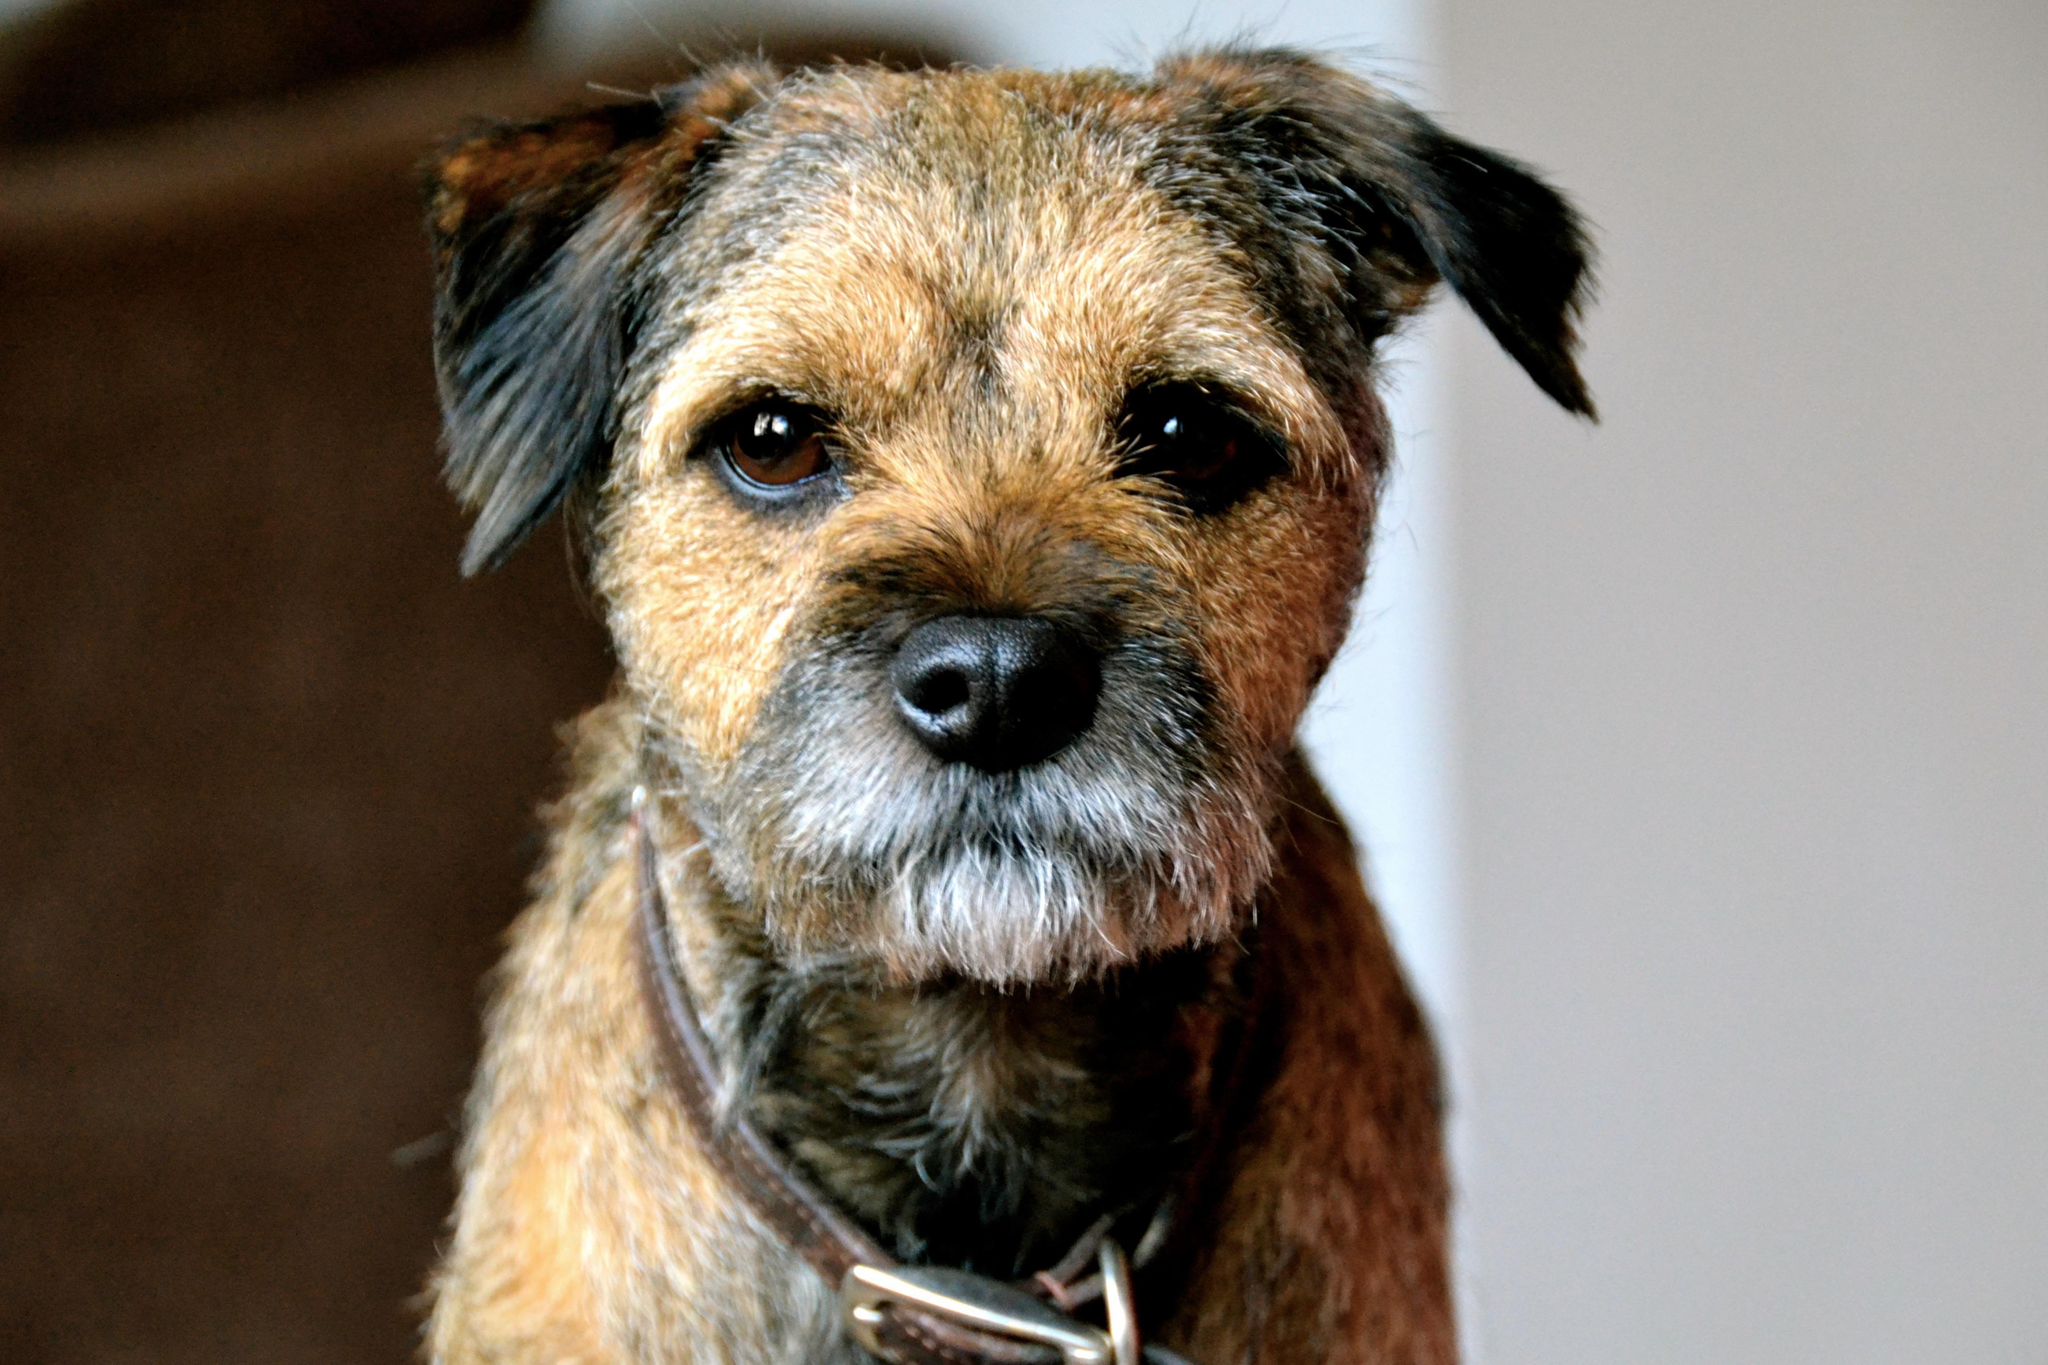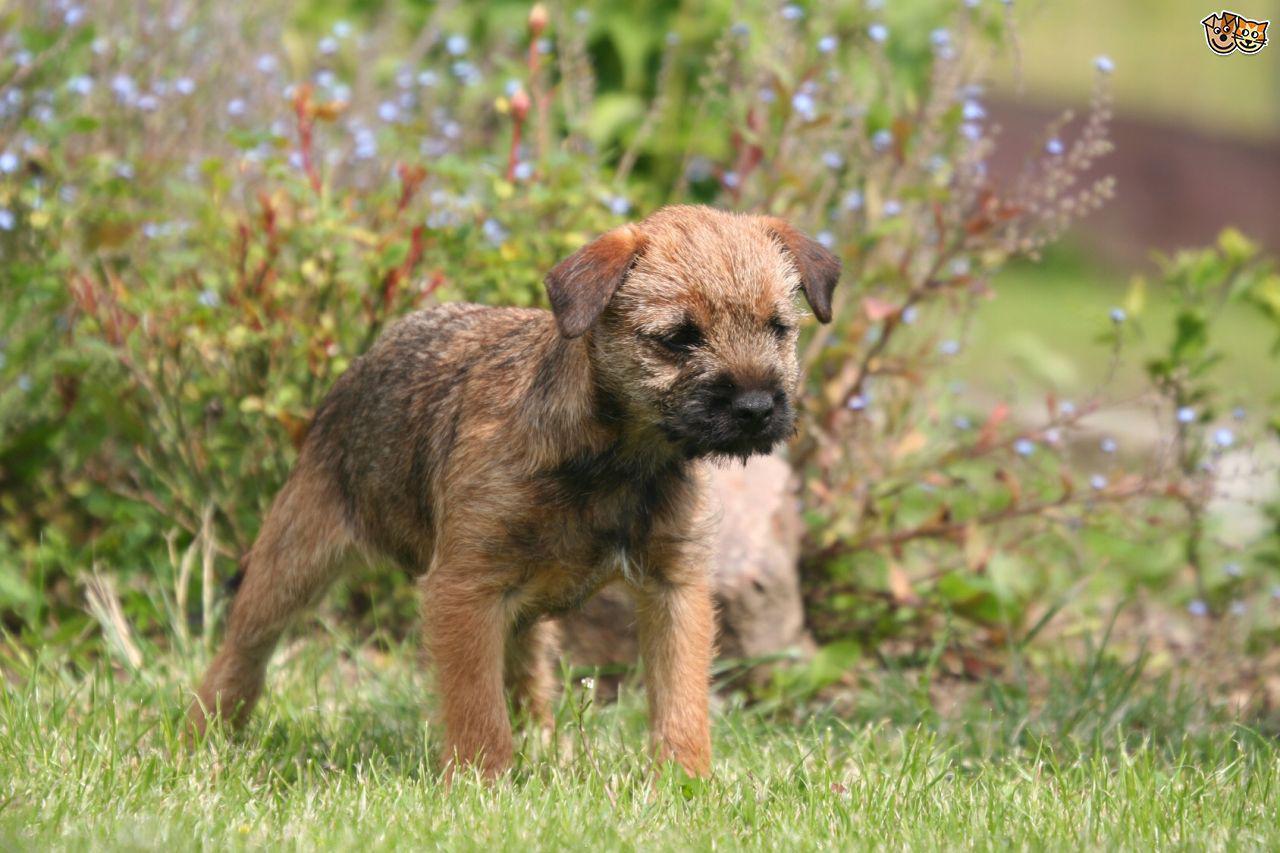The first image is the image on the left, the second image is the image on the right. Given the left and right images, does the statement "At least one of the dogs has its tongue sticking out." hold true? Answer yes or no. No. 